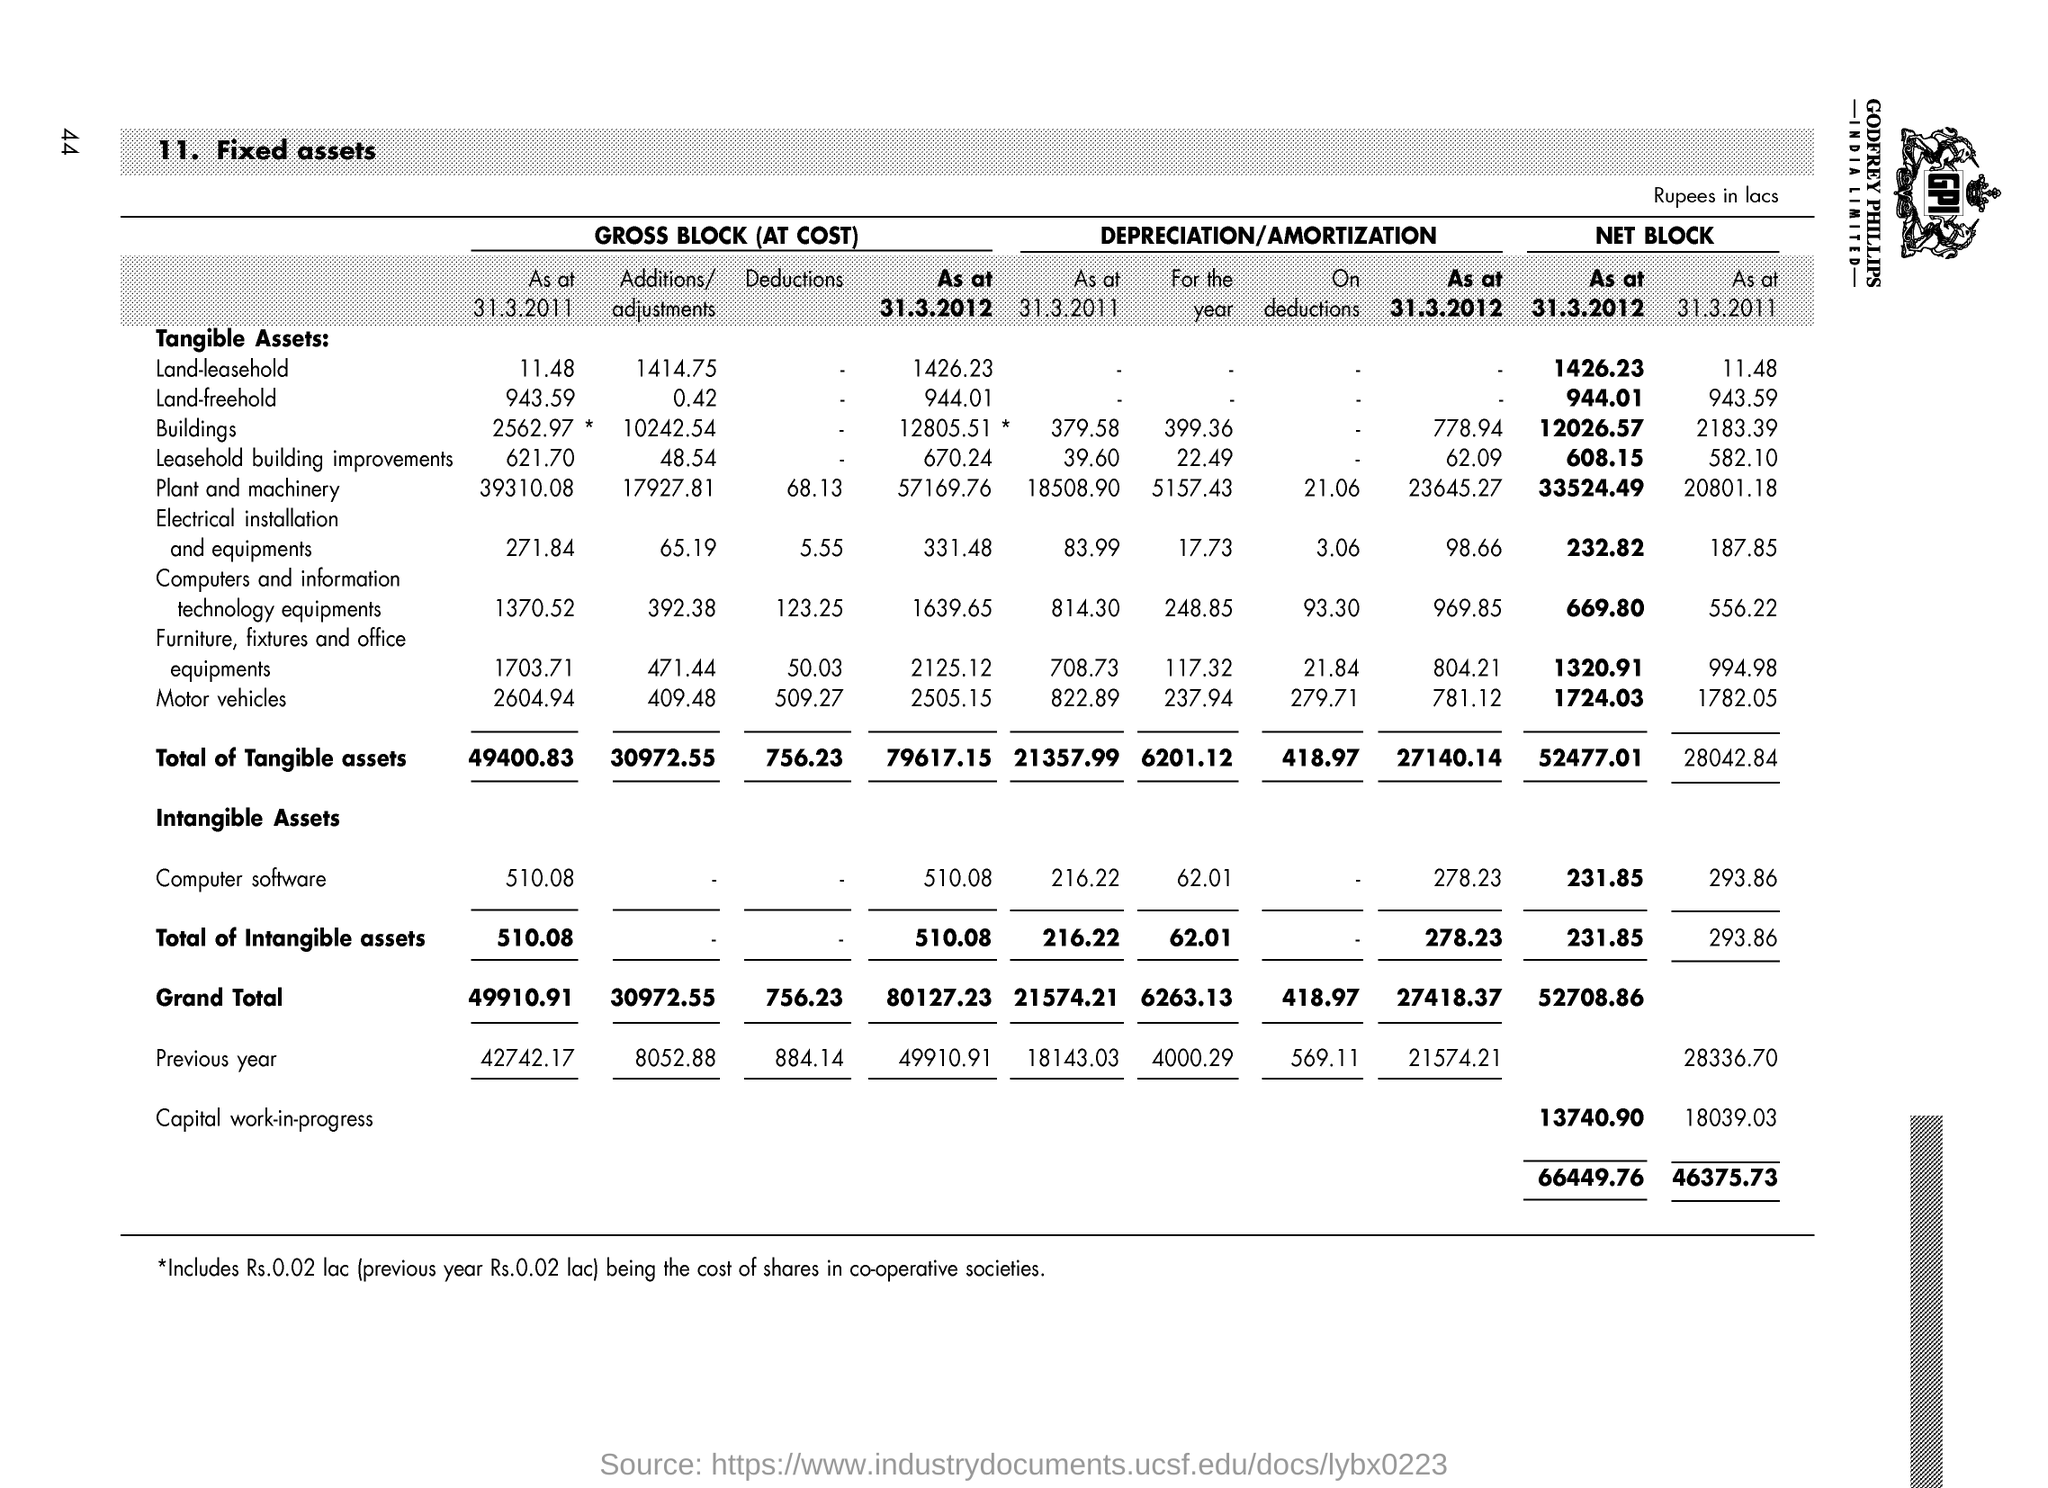Give some essential details in this illustration. The total of intangible assets for the gross block (at cost) as of March 31, 2011, was 510.08. The grand total for net block as of March 31, 2012 is $52,708.86. The grand total for the gross block (at cost) as of March 31, 2012, is 80,127.23. The total amount of tangible assets for the gross block (at cost) as of March 31, 2011, is 49,400.83. The total amount of intangible assets for the net block as of March 31, 2012, was 231.85. 